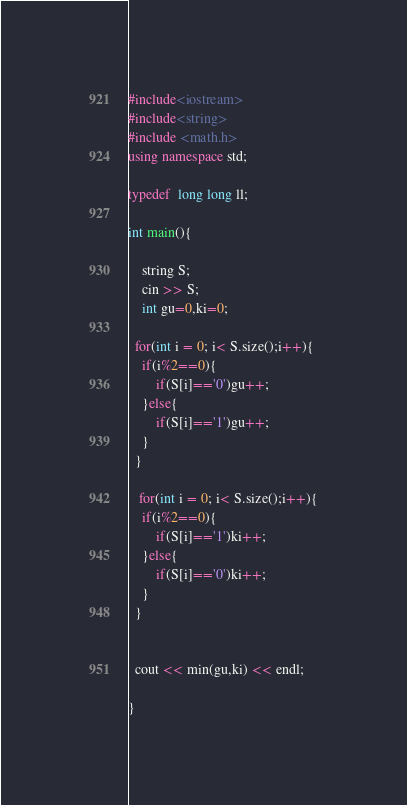<code> <loc_0><loc_0><loc_500><loc_500><_C++_>#include<iostream>
#include<string>
#include <math.h>
using namespace std;

typedef  long long ll;

int main(){
	
  	string S;
  	cin >> S;
	int gu=0,ki=0;
  	
  for(int i = 0; i< S.size();i++){
  	if(i%2==0){
    	if(S[i]=='0')gu++;
    }else{
    	if(S[i]=='1')gu++;
    }
  }
  
   for(int i = 0; i< S.size();i++){
  	if(i%2==0){
    	if(S[i]=='1')ki++;
    }else{
    	if(S[i]=='0')ki++;
    }
  }
  

  cout << min(gu,ki) << endl;
  
}</code> 